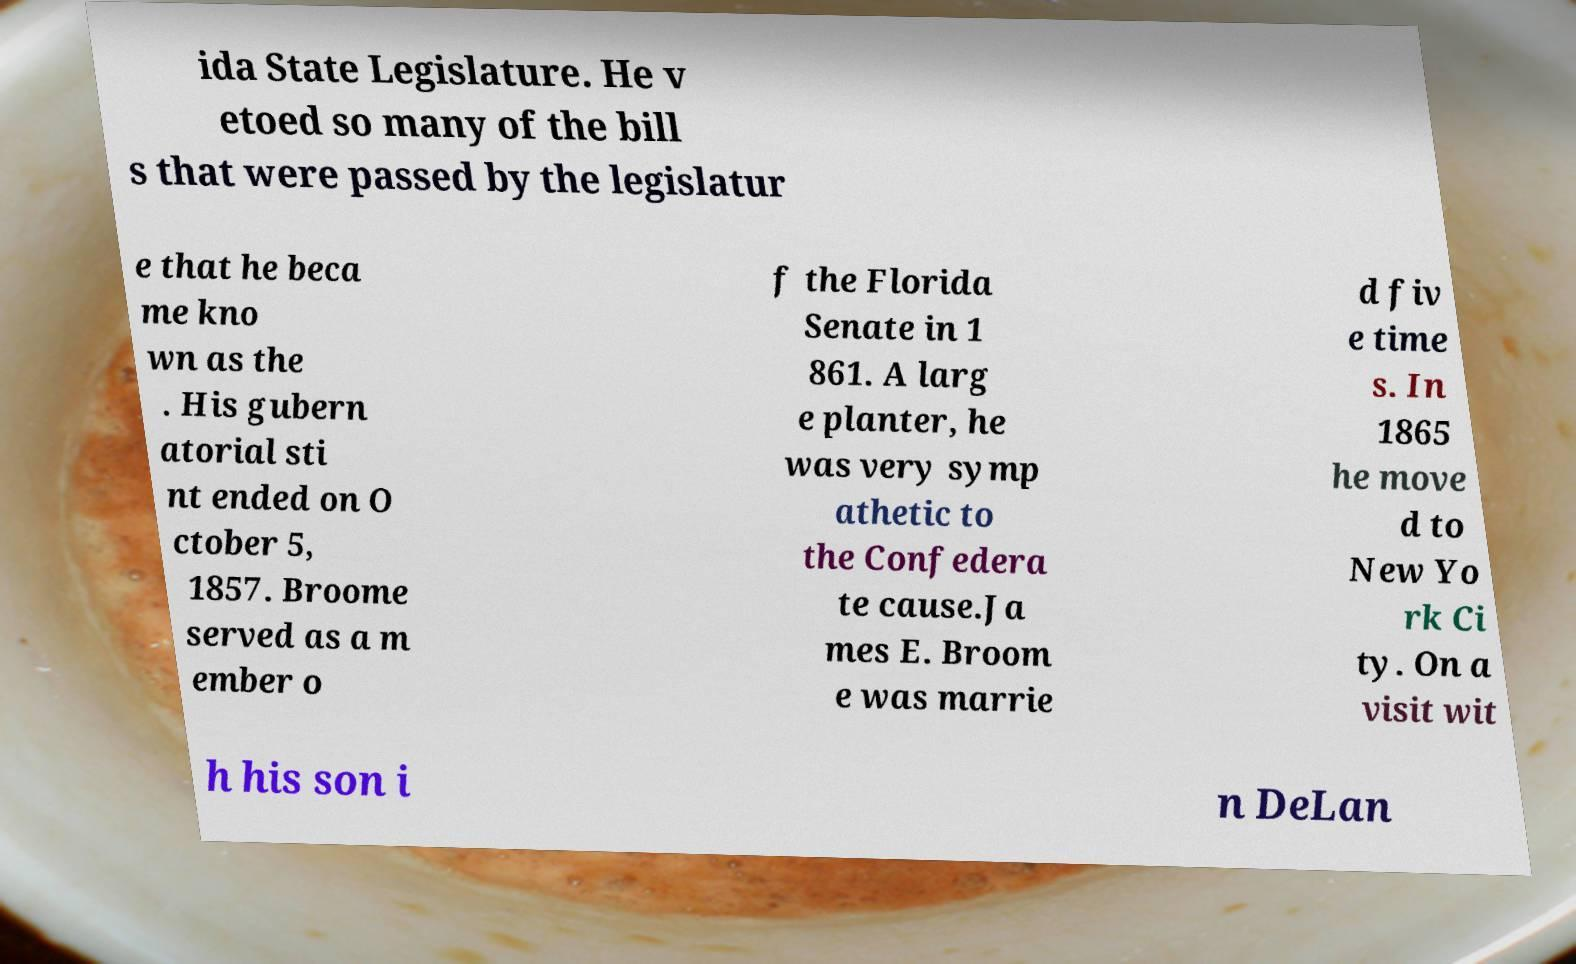For documentation purposes, I need the text within this image transcribed. Could you provide that? ida State Legislature. He v etoed so many of the bill s that were passed by the legislatur e that he beca me kno wn as the . His gubern atorial sti nt ended on O ctober 5, 1857. Broome served as a m ember o f the Florida Senate in 1 861. A larg e planter, he was very symp athetic to the Confedera te cause.Ja mes E. Broom e was marrie d fiv e time s. In 1865 he move d to New Yo rk Ci ty. On a visit wit h his son i n DeLan 